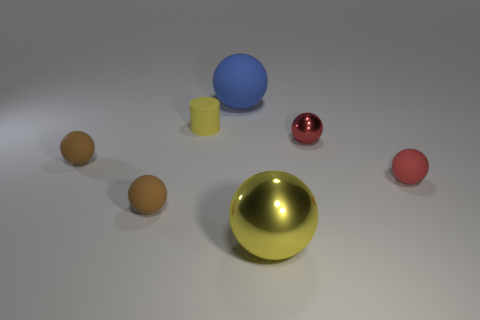Is the material of the yellow thing to the left of the yellow shiny ball the same as the large blue ball?
Your response must be concise. Yes. What number of spheres are both on the right side of the large metal sphere and behind the small cylinder?
Your answer should be very brief. 0. There is a rubber thing that is in front of the small rubber sphere that is to the right of the large blue rubber object; what is its size?
Ensure brevity in your answer.  Small. Is there any other thing that is the same material as the cylinder?
Your answer should be very brief. Yes. Are there more blue rubber objects than big cyan cylinders?
Your answer should be compact. Yes. Do the big sphere that is in front of the small yellow cylinder and the small cylinder behind the large yellow object have the same color?
Provide a succinct answer. Yes. There is a large sphere that is on the right side of the blue object; is there a big blue thing that is to the left of it?
Offer a very short reply. Yes. Is the number of big things behind the red metallic ball less than the number of things to the right of the large blue ball?
Give a very brief answer. Yes. Is the yellow object that is left of the big blue rubber ball made of the same material as the large object that is on the left side of the yellow metal thing?
Provide a succinct answer. Yes. What number of small things are blue rubber balls or yellow metallic balls?
Your answer should be compact. 0. 